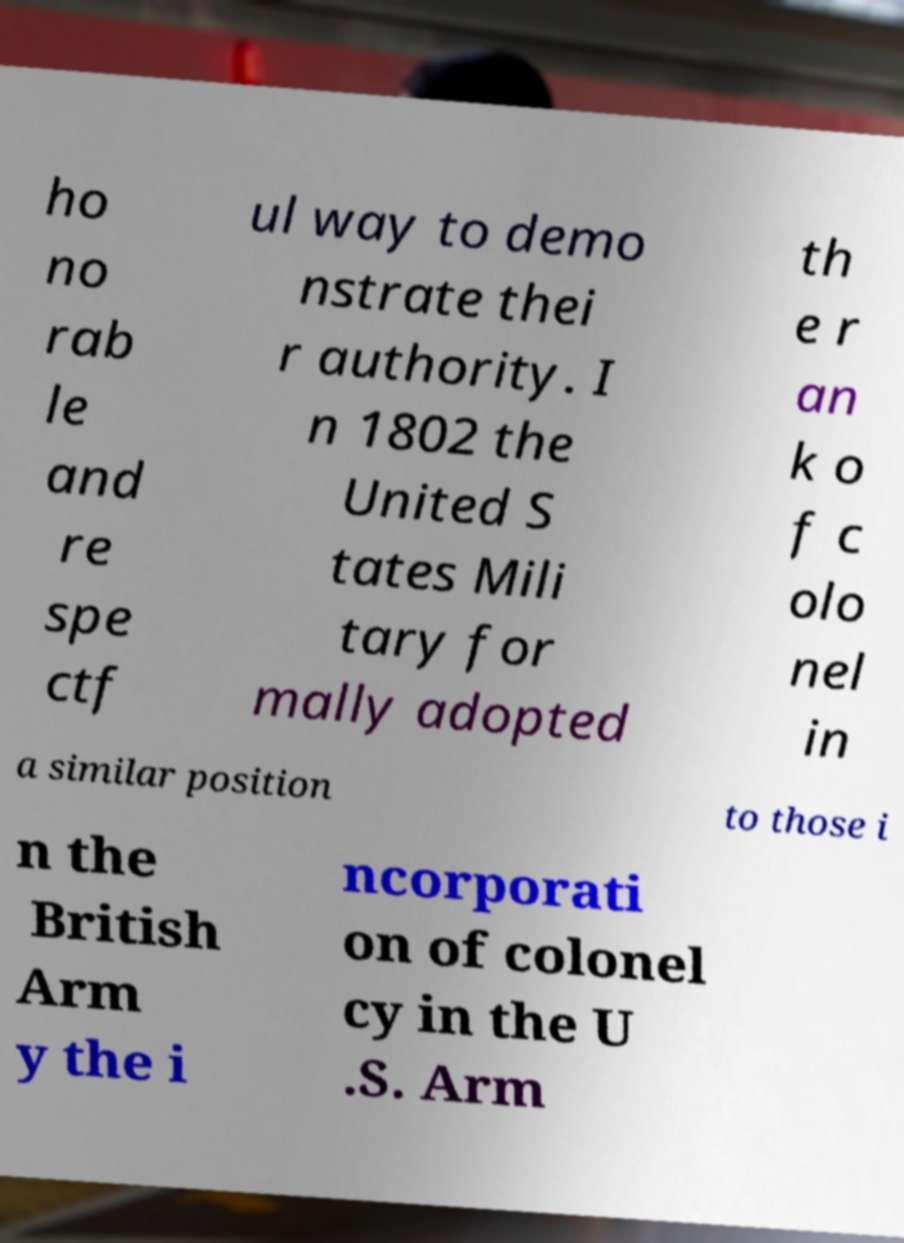For documentation purposes, I need the text within this image transcribed. Could you provide that? ho no rab le and re spe ctf ul way to demo nstrate thei r authority. I n 1802 the United S tates Mili tary for mally adopted th e r an k o f c olo nel in a similar position to those i n the British Arm y the i ncorporati on of colonel cy in the U .S. Arm 